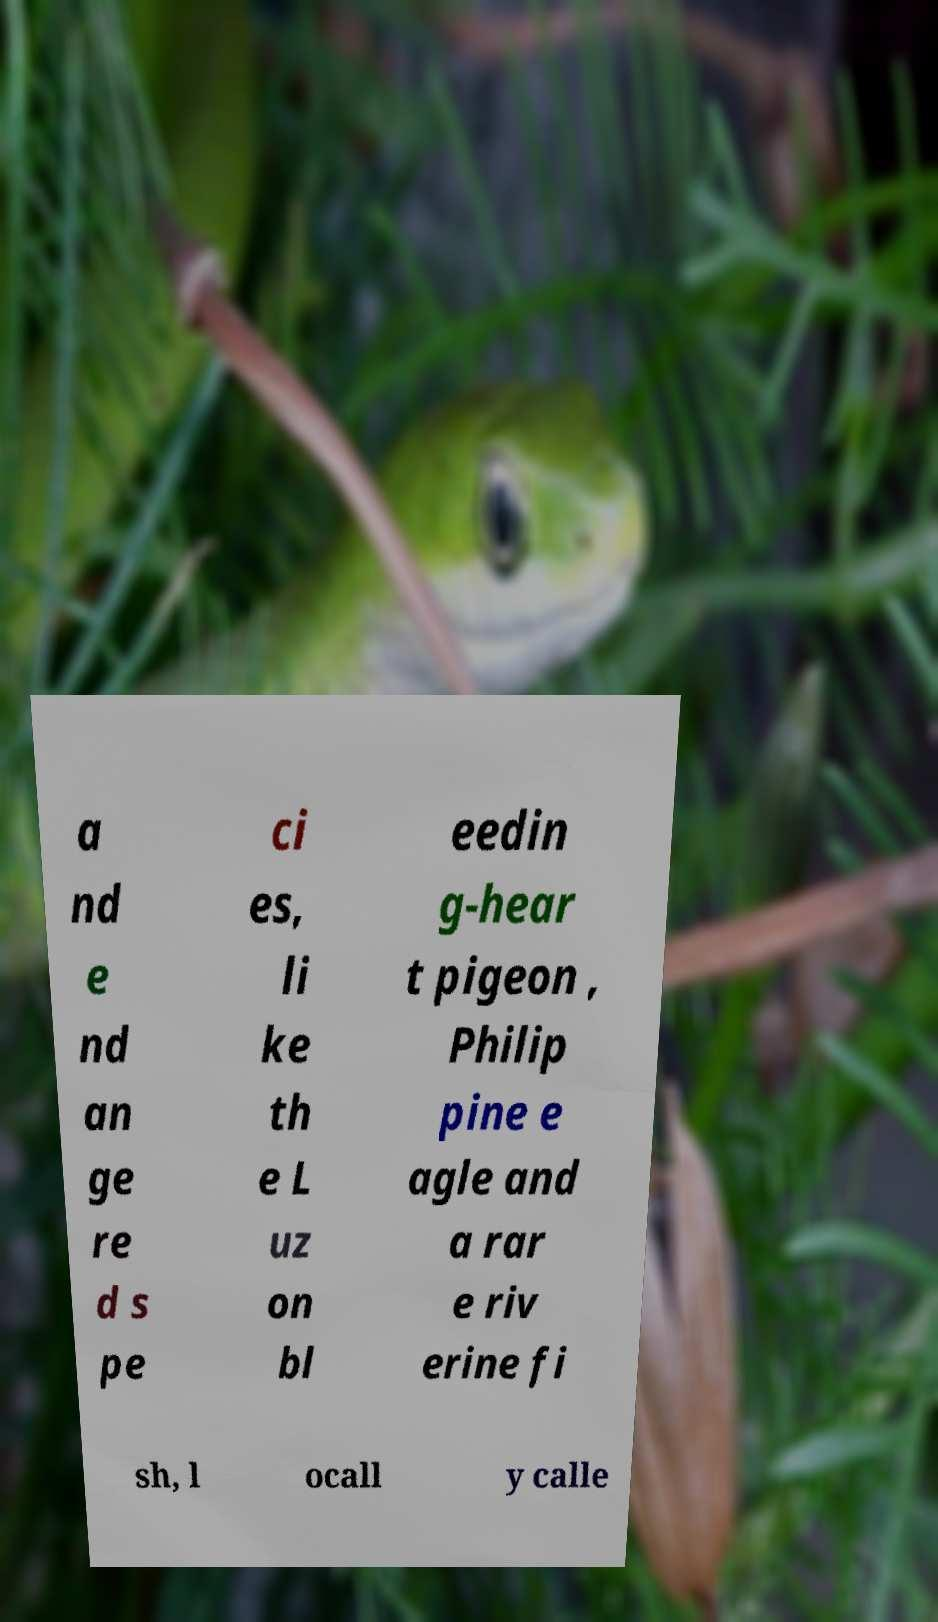For documentation purposes, I need the text within this image transcribed. Could you provide that? a nd e nd an ge re d s pe ci es, li ke th e L uz on bl eedin g-hear t pigeon , Philip pine e agle and a rar e riv erine fi sh, l ocall y calle 